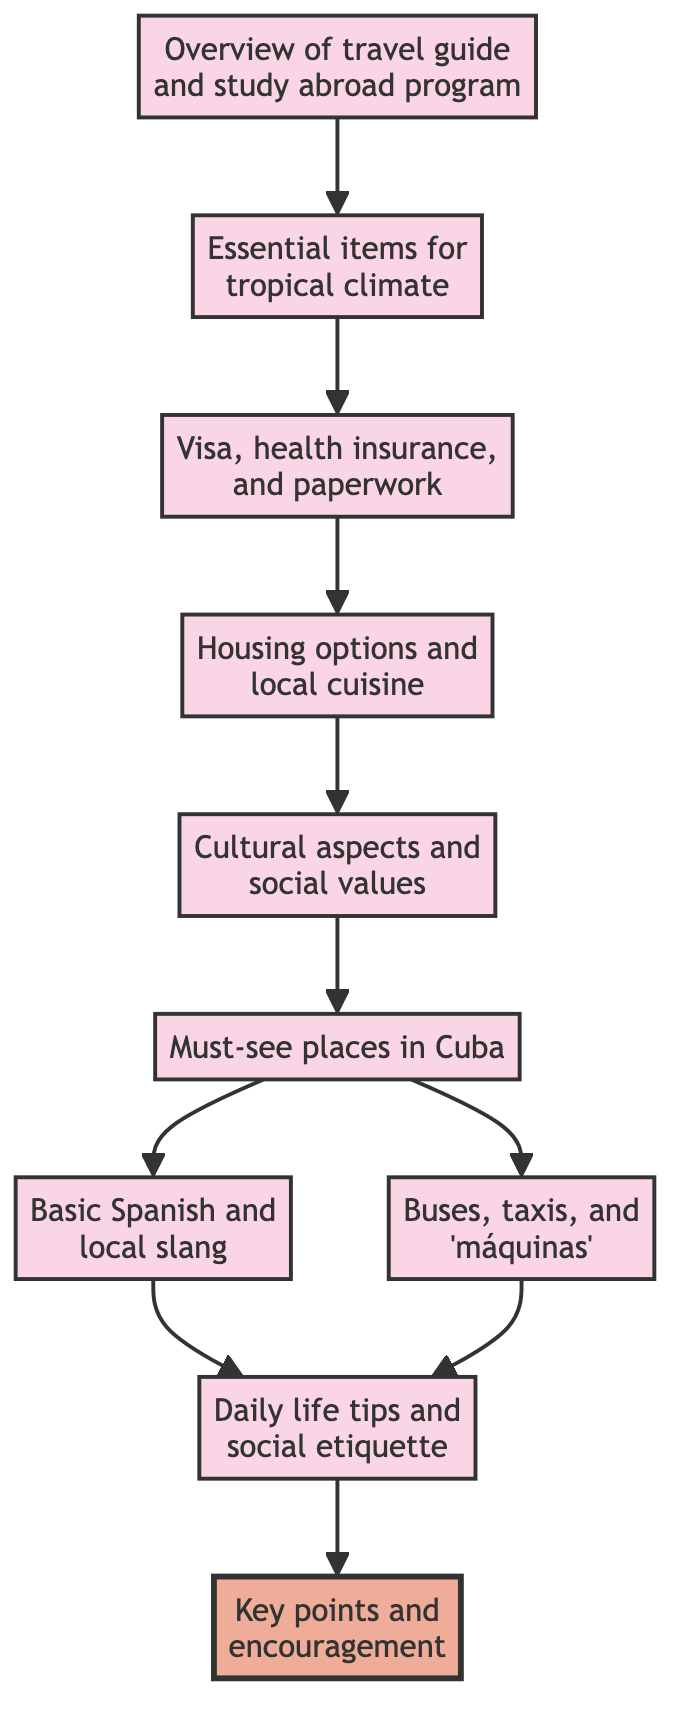What is the first node in the flowchart? The first node in the flowchart is "Introduction," which serves as the starting point for the travel guide preparation process.
Answer: Introduction How many nodes are there in total? There are ten nodes in the flowchart, representing different stages in preparing the travel guide.
Answer: 10 What is the last node in the flowchart? The last node in the flowchart is "Conclusion," which summarizes the travel guide's key points and encourages exploration.
Answer: Conclusion Which nodes lead to "Day-to-Day Experiences"? "Language Essentials" and "Local Transportation" are the nodes that lead to "Day-to-Day Experiences," indicating they provide key background before discussing daily life tips.
Answer: Language Essentials, Local Transportation What are the two main types of transportation mentioned in the flowchart? The two main types of transportation mentioned in the flowchart are "buses" and "taxis," which are recommended for getting around in Cuba.
Answer: buses, taxis Which node contains information about finding accommodation? The node that contains information about finding accommodation is "Accommodation and Food," detailing where to stay and what local cuisine to try.
Answer: Accommodation and Food What section provides insights on local cultural aspects? The section that provides insights on local cultural aspects is "Cultural Understanding," which covers important historical and social values in Cuba.
Answer: Cultural Understanding What must be completed before reaching "Accommodation and Food"? Before reaching "Accommodation and Food," the steps "Travel Documentation" must be completed, which includes obtaining necessary visas and paperwork.
Answer: Travel Documentation Which two nodes provide tips before getting to "Day-to-Day Experiences"? The two nodes that provide tips before getting to "Day-to-Day Experiences" are "Language Essentials" and "Local Transportation," which prepare students for practical interactions and travel.
Answer: Language Essentials, Local Transportation 